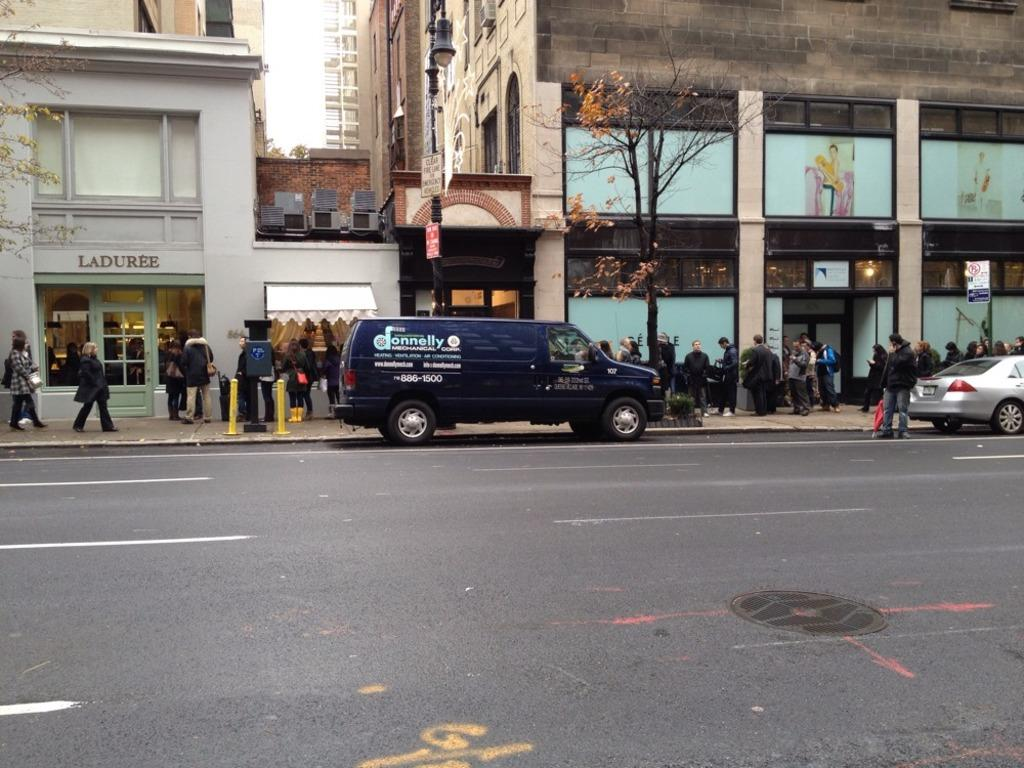<image>
Describe the image concisely. A Donnelly van is parked outside of Laduree. 